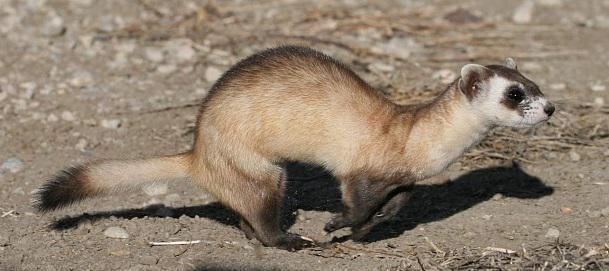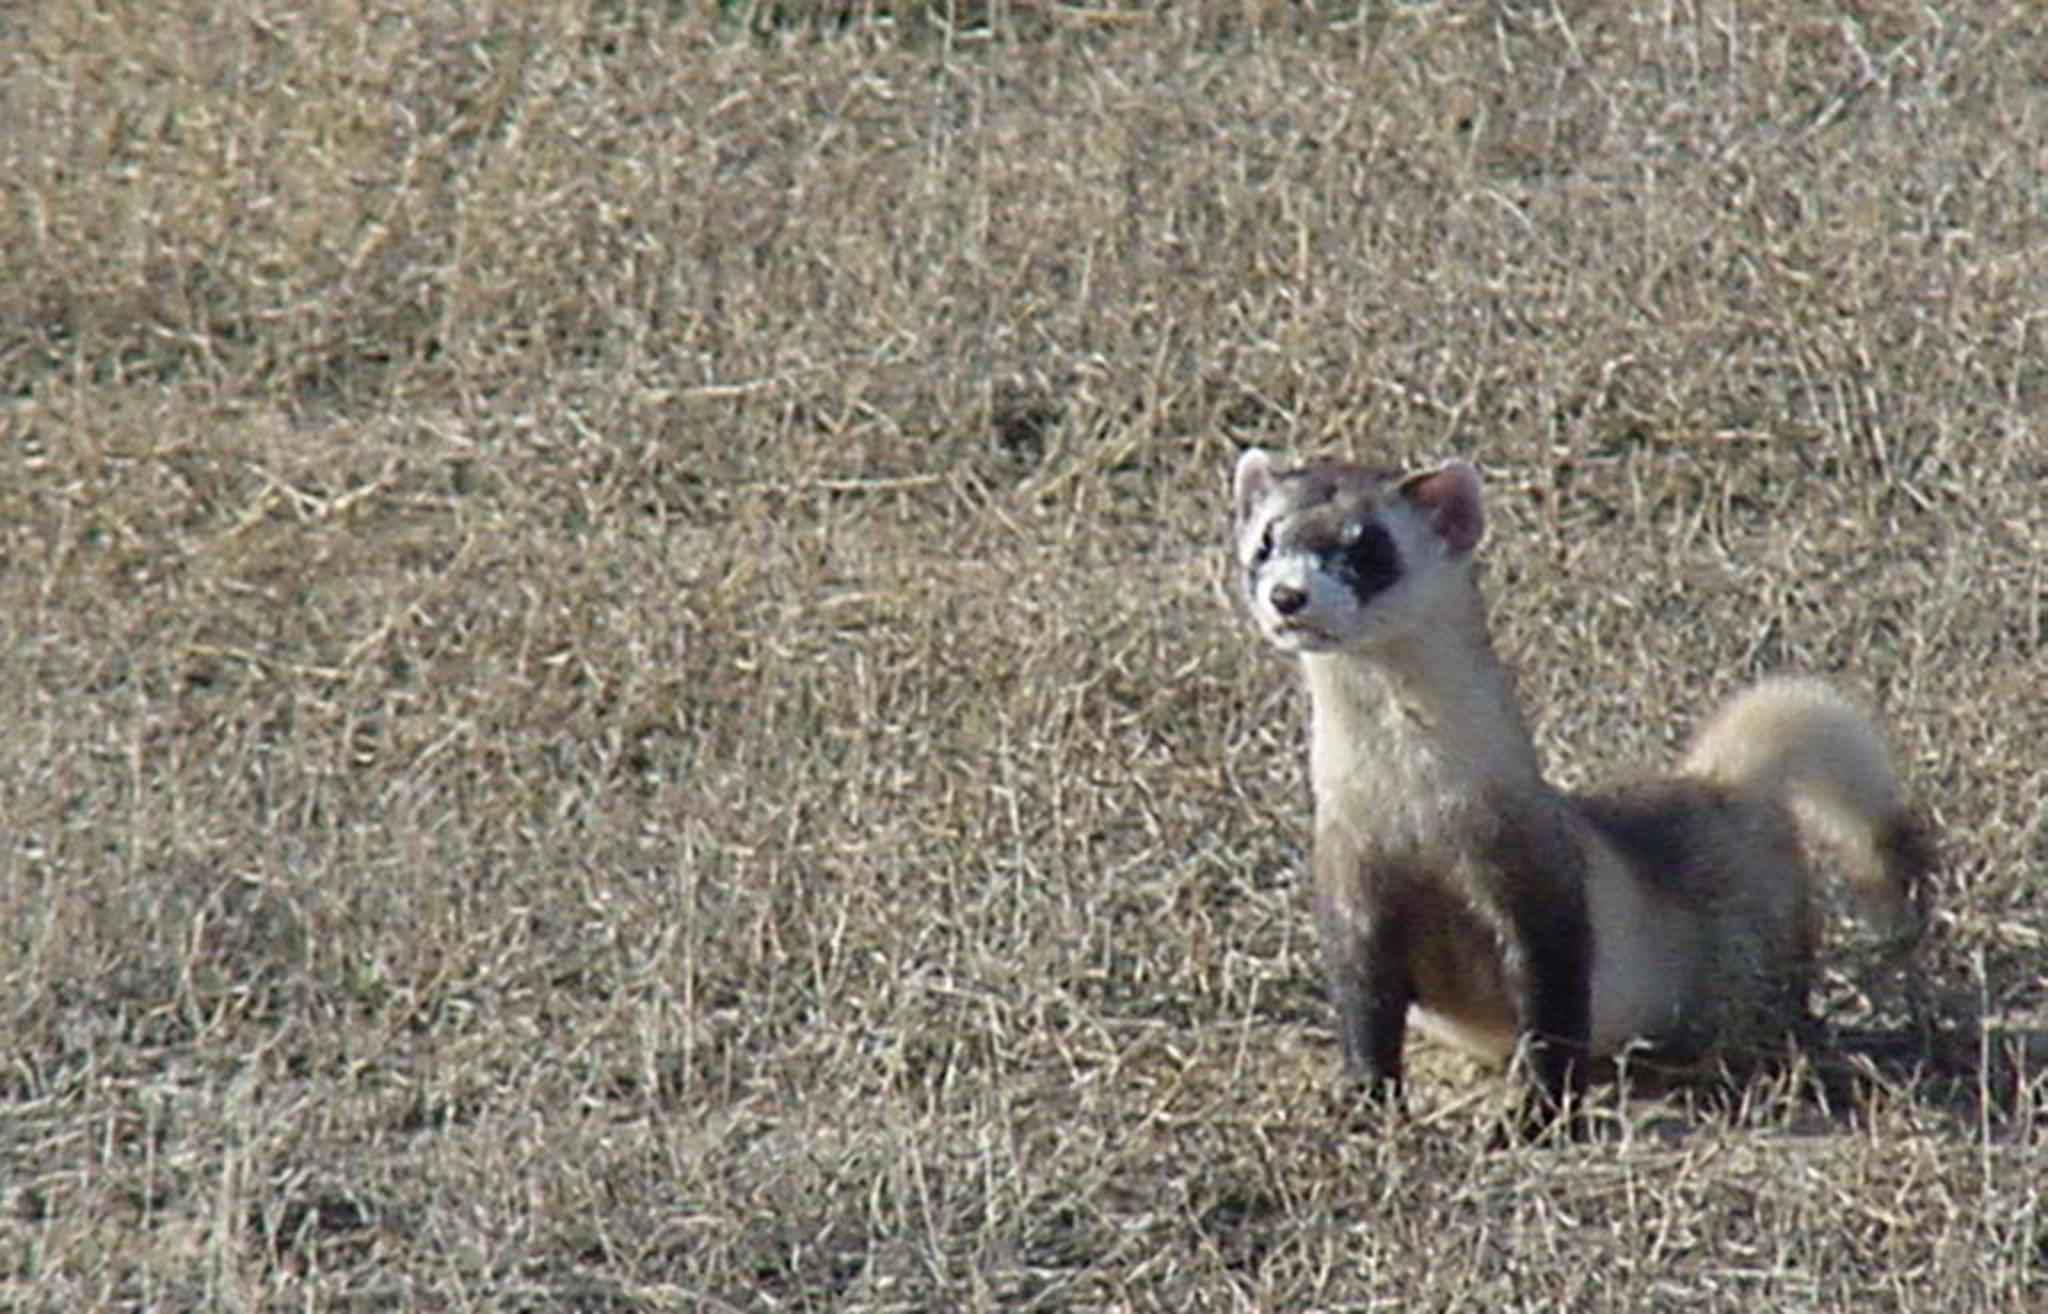The first image is the image on the left, the second image is the image on the right. Assess this claim about the two images: "The animal in one of the images has its body turned toward the bottom left". Correct or not? Answer yes or no. Yes. 